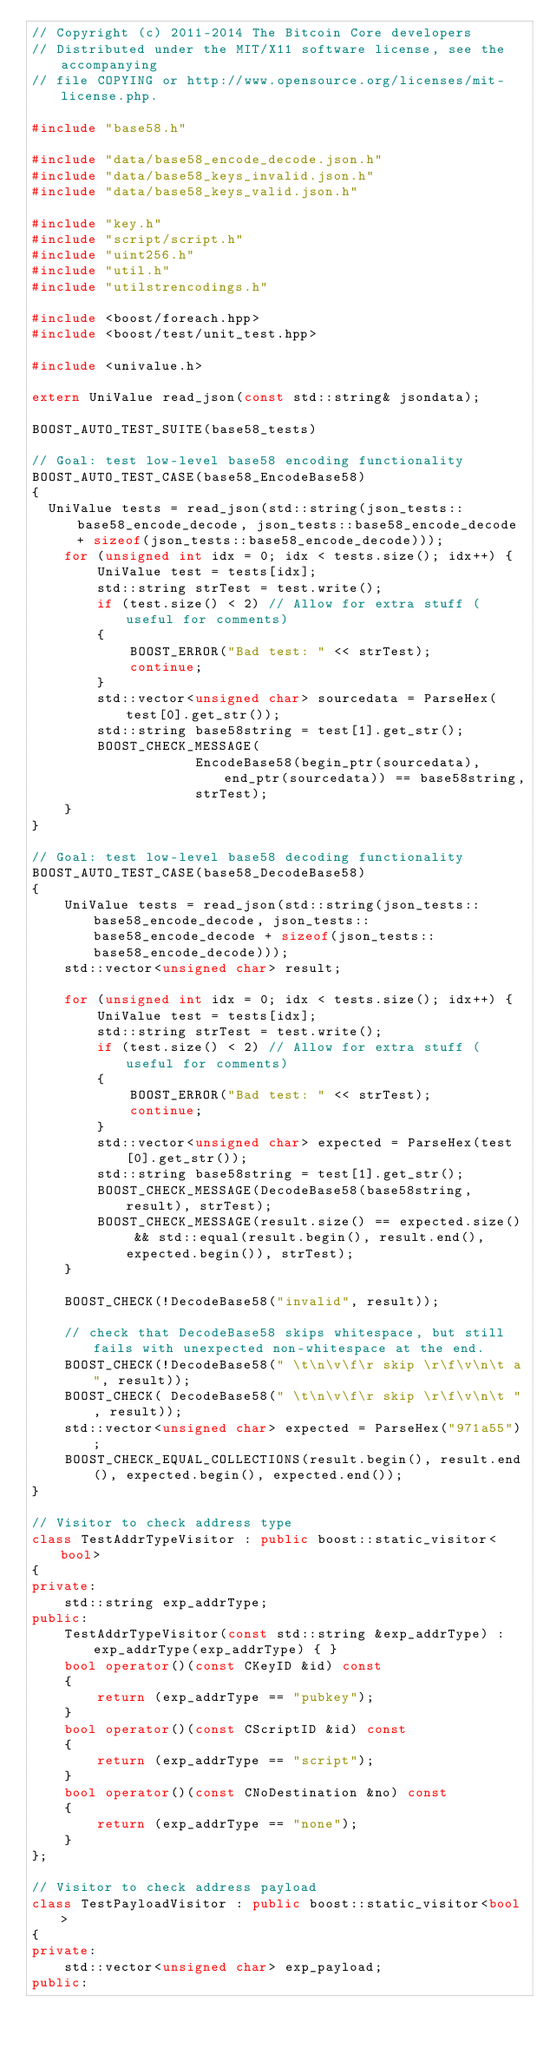Convert code to text. <code><loc_0><loc_0><loc_500><loc_500><_C++_>// Copyright (c) 2011-2014 The Bitcoin Core developers
// Distributed under the MIT/X11 software license, see the accompanying
// file COPYING or http://www.opensource.org/licenses/mit-license.php.

#include "base58.h"

#include "data/base58_encode_decode.json.h"
#include "data/base58_keys_invalid.json.h"
#include "data/base58_keys_valid.json.h"

#include "key.h"
#include "script/script.h"
#include "uint256.h"
#include "util.h"
#include "utilstrencodings.h"

#include <boost/foreach.hpp>
#include <boost/test/unit_test.hpp>

#include <univalue.h>

extern UniValue read_json(const std::string& jsondata);

BOOST_AUTO_TEST_SUITE(base58_tests)

// Goal: test low-level base58 encoding functionality
BOOST_AUTO_TEST_CASE(base58_EncodeBase58)
{
	UniValue tests = read_json(std::string(json_tests::base58_encode_decode, json_tests::base58_encode_decode + sizeof(json_tests::base58_encode_decode)));
    for (unsigned int idx = 0; idx < tests.size(); idx++) {
        UniValue test = tests[idx];
        std::string strTest = test.write();
        if (test.size() < 2) // Allow for extra stuff (useful for comments)
        {
            BOOST_ERROR("Bad test: " << strTest);
            continue;
        }
        std::vector<unsigned char> sourcedata = ParseHex(test[0].get_str());
        std::string base58string = test[1].get_str();
        BOOST_CHECK_MESSAGE(
                    EncodeBase58(begin_ptr(sourcedata), end_ptr(sourcedata)) == base58string,
                    strTest);
    }
}

// Goal: test low-level base58 decoding functionality
BOOST_AUTO_TEST_CASE(base58_DecodeBase58)
{
    UniValue tests = read_json(std::string(json_tests::base58_encode_decode, json_tests::base58_encode_decode + sizeof(json_tests::base58_encode_decode)));
    std::vector<unsigned char> result;

    for (unsigned int idx = 0; idx < tests.size(); idx++) {
        UniValue test = tests[idx];
        std::string strTest = test.write();
        if (test.size() < 2) // Allow for extra stuff (useful for comments)
        {
            BOOST_ERROR("Bad test: " << strTest);
            continue;
        }
        std::vector<unsigned char> expected = ParseHex(test[0].get_str());
        std::string base58string = test[1].get_str();
        BOOST_CHECK_MESSAGE(DecodeBase58(base58string, result), strTest);
        BOOST_CHECK_MESSAGE(result.size() == expected.size() && std::equal(result.begin(), result.end(), expected.begin()), strTest);
    }

    BOOST_CHECK(!DecodeBase58("invalid", result));

    // check that DecodeBase58 skips whitespace, but still fails with unexpected non-whitespace at the end.
    BOOST_CHECK(!DecodeBase58(" \t\n\v\f\r skip \r\f\v\n\t a", result));
    BOOST_CHECK( DecodeBase58(" \t\n\v\f\r skip \r\f\v\n\t ", result));
    std::vector<unsigned char> expected = ParseHex("971a55");
    BOOST_CHECK_EQUAL_COLLECTIONS(result.begin(), result.end(), expected.begin(), expected.end());
}

// Visitor to check address type
class TestAddrTypeVisitor : public boost::static_visitor<bool>
{
private:
    std::string exp_addrType;
public:
    TestAddrTypeVisitor(const std::string &exp_addrType) : exp_addrType(exp_addrType) { }
    bool operator()(const CKeyID &id) const
    {
        return (exp_addrType == "pubkey");
    }
    bool operator()(const CScriptID &id) const
    {
        return (exp_addrType == "script");
    }
    bool operator()(const CNoDestination &no) const
    {
        return (exp_addrType == "none");
    }
};

// Visitor to check address payload
class TestPayloadVisitor : public boost::static_visitor<bool>
{
private:
    std::vector<unsigned char> exp_payload;
public:</code> 